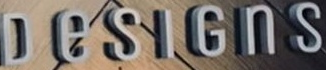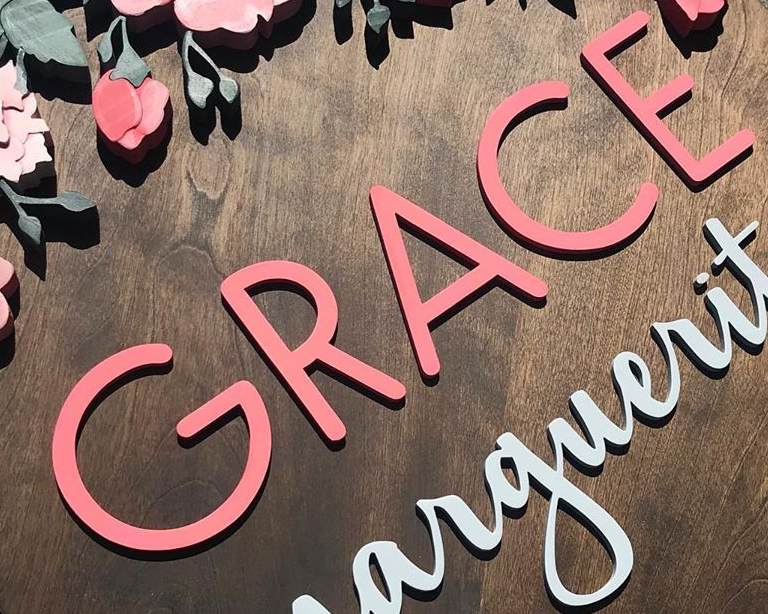What text is displayed in these images sequentially, separated by a semicolon? DeSIGnS; GRACE 